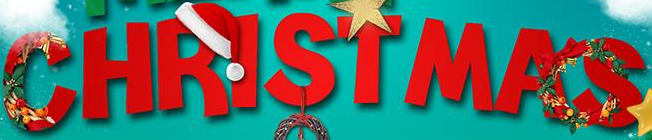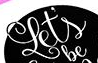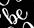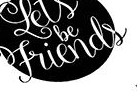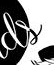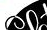Read the text from these images in sequence, separated by a semicolon. CHRISTMAS; Let's; be; Friends; ds; ## 